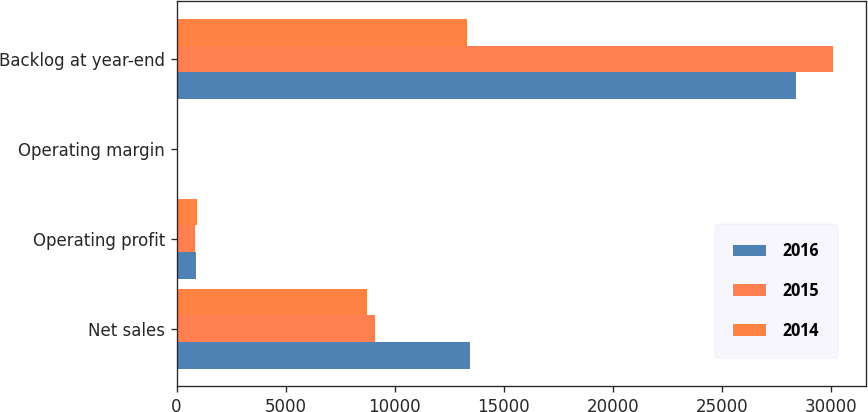Convert chart. <chart><loc_0><loc_0><loc_500><loc_500><stacked_bar_chart><ecel><fcel>Net sales<fcel>Operating profit<fcel>Operating margin<fcel>Backlog at year-end<nl><fcel>2016<fcel>13462<fcel>906<fcel>6.7<fcel>28400<nl><fcel>2015<fcel>9091<fcel>844<fcel>9.3<fcel>30100<nl><fcel>2014<fcel>8732<fcel>936<fcel>10.7<fcel>13300<nl></chart> 